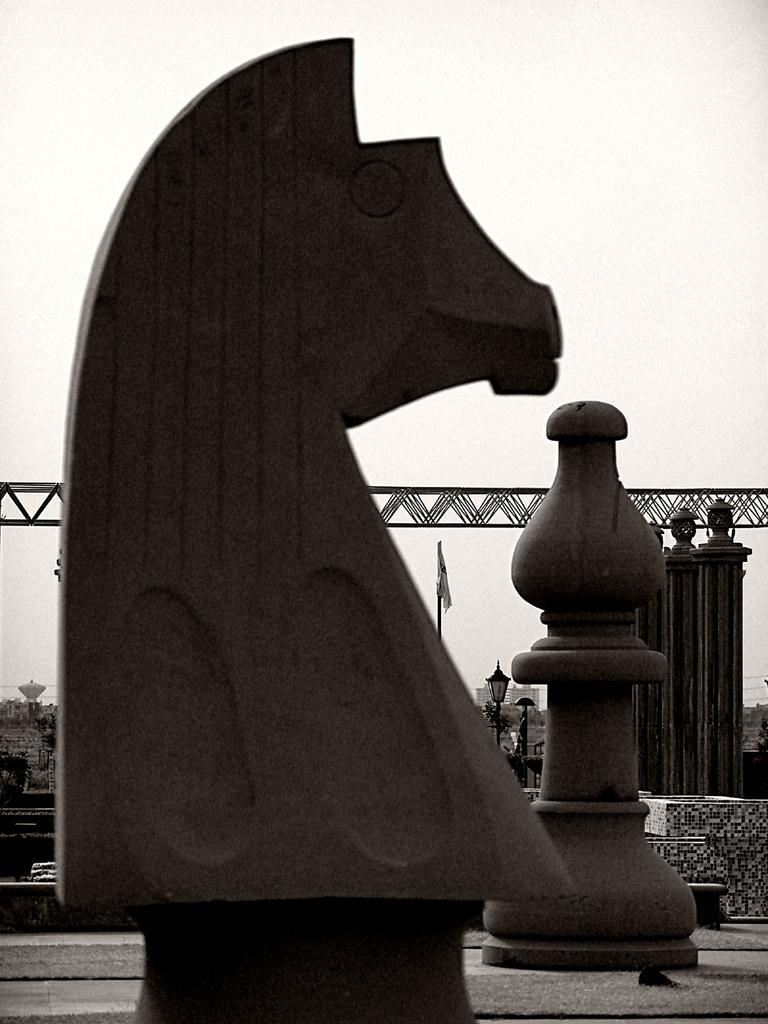In one or two sentences, can you explain what this image depicts? In the picture we can see a sculpture of chess coins and behind it, we can see some poles with lamps and one pole with flag and behind it we can see a sky. 